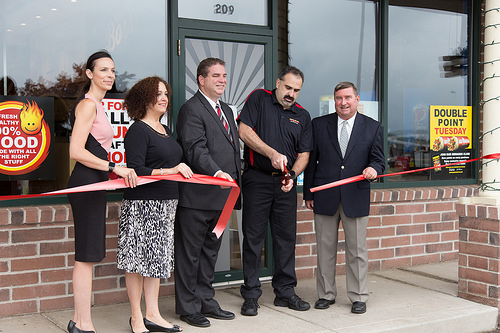<image>
Is the sign to the right of the man? Yes. From this viewpoint, the sign is positioned to the right side relative to the man. 